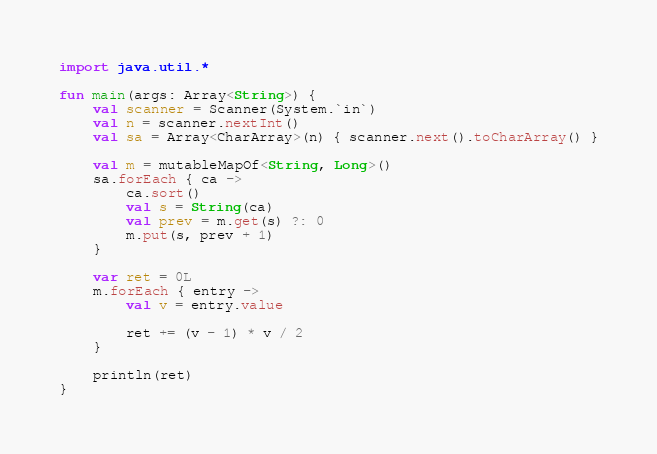<code> <loc_0><loc_0><loc_500><loc_500><_Kotlin_>import java.util.*

fun main(args: Array<String>) {
    val scanner = Scanner(System.`in`)
    val n = scanner.nextInt()
    val sa = Array<CharArray>(n) { scanner.next().toCharArray() }

    val m = mutableMapOf<String, Long>()
    sa.forEach { ca ->
        ca.sort()
        val s = String(ca)
        val prev = m.get(s) ?: 0
        m.put(s, prev + 1)
    }

    var ret = 0L
    m.forEach { entry ->
        val v = entry.value

        ret += (v - 1) * v / 2
    }

    println(ret)
}</code> 